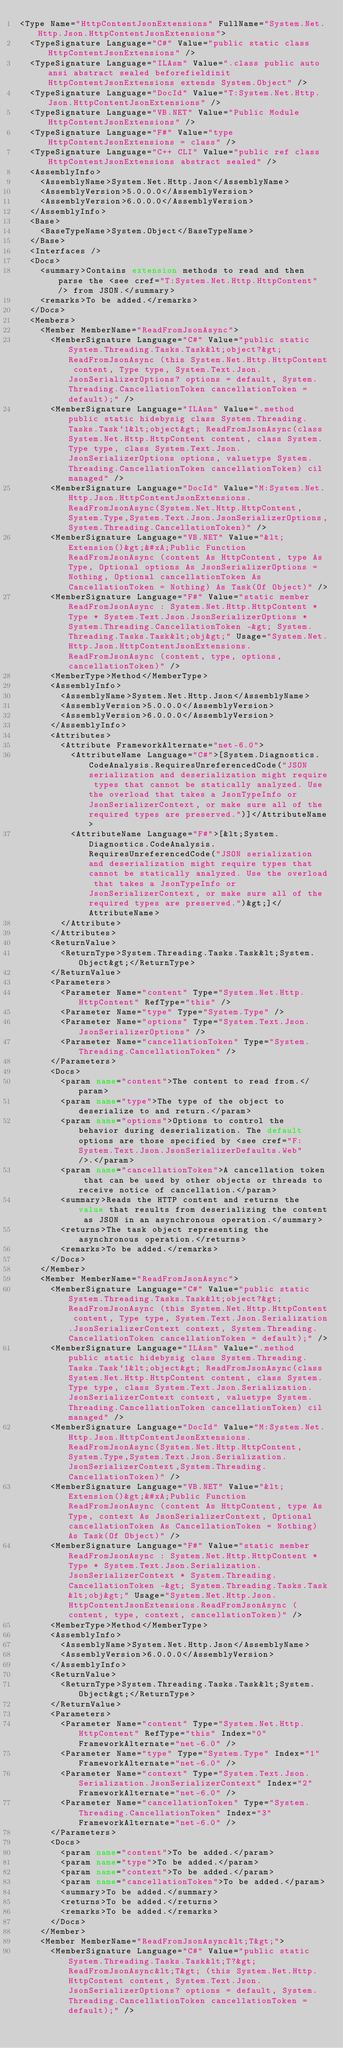Convert code to text. <code><loc_0><loc_0><loc_500><loc_500><_XML_><Type Name="HttpContentJsonExtensions" FullName="System.Net.Http.Json.HttpContentJsonExtensions">
  <TypeSignature Language="C#" Value="public static class HttpContentJsonExtensions" />
  <TypeSignature Language="ILAsm" Value=".class public auto ansi abstract sealed beforefieldinit HttpContentJsonExtensions extends System.Object" />
  <TypeSignature Language="DocId" Value="T:System.Net.Http.Json.HttpContentJsonExtensions" />
  <TypeSignature Language="VB.NET" Value="Public Module HttpContentJsonExtensions" />
  <TypeSignature Language="F#" Value="type HttpContentJsonExtensions = class" />
  <TypeSignature Language="C++ CLI" Value="public ref class HttpContentJsonExtensions abstract sealed" />
  <AssemblyInfo>
    <AssemblyName>System.Net.Http.Json</AssemblyName>
    <AssemblyVersion>5.0.0.0</AssemblyVersion>
    <AssemblyVersion>6.0.0.0</AssemblyVersion>
  </AssemblyInfo>
  <Base>
    <BaseTypeName>System.Object</BaseTypeName>
  </Base>
  <Interfaces />
  <Docs>
    <summary>Contains extension methods to read and then parse the <see cref="T:System.Net.Http.HttpContent" /> from JSON.</summary>
    <remarks>To be added.</remarks>
  </Docs>
  <Members>
    <Member MemberName="ReadFromJsonAsync">
      <MemberSignature Language="C#" Value="public static System.Threading.Tasks.Task&lt;object?&gt; ReadFromJsonAsync (this System.Net.Http.HttpContent content, Type type, System.Text.Json.JsonSerializerOptions? options = default, System.Threading.CancellationToken cancellationToken = default);" />
      <MemberSignature Language="ILAsm" Value=".method public static hidebysig class System.Threading.Tasks.Task`1&lt;object&gt; ReadFromJsonAsync(class System.Net.Http.HttpContent content, class System.Type type, class System.Text.Json.JsonSerializerOptions options, valuetype System.Threading.CancellationToken cancellationToken) cil managed" />
      <MemberSignature Language="DocId" Value="M:System.Net.Http.Json.HttpContentJsonExtensions.ReadFromJsonAsync(System.Net.Http.HttpContent,System.Type,System.Text.Json.JsonSerializerOptions,System.Threading.CancellationToken)" />
      <MemberSignature Language="VB.NET" Value="&lt;Extension()&gt;&#xA;Public Function ReadFromJsonAsync (content As HttpContent, type As Type, Optional options As JsonSerializerOptions = Nothing, Optional cancellationToken As CancellationToken = Nothing) As Task(Of Object)" />
      <MemberSignature Language="F#" Value="static member ReadFromJsonAsync : System.Net.Http.HttpContent * Type * System.Text.Json.JsonSerializerOptions * System.Threading.CancellationToken -&gt; System.Threading.Tasks.Task&lt;obj&gt;" Usage="System.Net.Http.Json.HttpContentJsonExtensions.ReadFromJsonAsync (content, type, options, cancellationToken)" />
      <MemberType>Method</MemberType>
      <AssemblyInfo>
        <AssemblyName>System.Net.Http.Json</AssemblyName>
        <AssemblyVersion>5.0.0.0</AssemblyVersion>
        <AssemblyVersion>6.0.0.0</AssemblyVersion>
      </AssemblyInfo>
      <Attributes>
        <Attribute FrameworkAlternate="net-6.0">
          <AttributeName Language="C#">[System.Diagnostics.CodeAnalysis.RequiresUnreferencedCode("JSON serialization and deserialization might require types that cannot be statically analyzed. Use the overload that takes a JsonTypeInfo or JsonSerializerContext, or make sure all of the required types are preserved.")]</AttributeName>
          <AttributeName Language="F#">[&lt;System.Diagnostics.CodeAnalysis.RequiresUnreferencedCode("JSON serialization and deserialization might require types that cannot be statically analyzed. Use the overload that takes a JsonTypeInfo or JsonSerializerContext, or make sure all of the required types are preserved.")&gt;]</AttributeName>
        </Attribute>
      </Attributes>
      <ReturnValue>
        <ReturnType>System.Threading.Tasks.Task&lt;System.Object&gt;</ReturnType>
      </ReturnValue>
      <Parameters>
        <Parameter Name="content" Type="System.Net.Http.HttpContent" RefType="this" />
        <Parameter Name="type" Type="System.Type" />
        <Parameter Name="options" Type="System.Text.Json.JsonSerializerOptions" />
        <Parameter Name="cancellationToken" Type="System.Threading.CancellationToken" />
      </Parameters>
      <Docs>
        <param name="content">The content to read from.</param>
        <param name="type">The type of the object to deserialize to and return.</param>
        <param name="options">Options to control the behavior during deserialization. The default options are those specified by <see cref="F:System.Text.Json.JsonSerializerDefaults.Web" />.</param>
        <param name="cancellationToken">A cancellation token that can be used by other objects or threads to receive notice of cancellation.</param>
        <summary>Reads the HTTP content and returns the value that results from deserializing the content as JSON in an asynchronous operation.</summary>
        <returns>The task object representing the asynchronous operation.</returns>
        <remarks>To be added.</remarks>
      </Docs>
    </Member>
    <Member MemberName="ReadFromJsonAsync">
      <MemberSignature Language="C#" Value="public static System.Threading.Tasks.Task&lt;object?&gt; ReadFromJsonAsync (this System.Net.Http.HttpContent content, Type type, System.Text.Json.Serialization.JsonSerializerContext context, System.Threading.CancellationToken cancellationToken = default);" />
      <MemberSignature Language="ILAsm" Value=".method public static hidebysig class System.Threading.Tasks.Task`1&lt;object&gt; ReadFromJsonAsync(class System.Net.Http.HttpContent content, class System.Type type, class System.Text.Json.Serialization.JsonSerializerContext context, valuetype System.Threading.CancellationToken cancellationToken) cil managed" />
      <MemberSignature Language="DocId" Value="M:System.Net.Http.Json.HttpContentJsonExtensions.ReadFromJsonAsync(System.Net.Http.HttpContent,System.Type,System.Text.Json.Serialization.JsonSerializerContext,System.Threading.CancellationToken)" />
      <MemberSignature Language="VB.NET" Value="&lt;Extension()&gt;&#xA;Public Function ReadFromJsonAsync (content As HttpContent, type As Type, context As JsonSerializerContext, Optional cancellationToken As CancellationToken = Nothing) As Task(Of Object)" />
      <MemberSignature Language="F#" Value="static member ReadFromJsonAsync : System.Net.Http.HttpContent * Type * System.Text.Json.Serialization.JsonSerializerContext * System.Threading.CancellationToken -&gt; System.Threading.Tasks.Task&lt;obj&gt;" Usage="System.Net.Http.Json.HttpContentJsonExtensions.ReadFromJsonAsync (content, type, context, cancellationToken)" />
      <MemberType>Method</MemberType>
      <AssemblyInfo>
        <AssemblyName>System.Net.Http.Json</AssemblyName>
        <AssemblyVersion>6.0.0.0</AssemblyVersion>
      </AssemblyInfo>
      <ReturnValue>
        <ReturnType>System.Threading.Tasks.Task&lt;System.Object&gt;</ReturnType>
      </ReturnValue>
      <Parameters>
        <Parameter Name="content" Type="System.Net.Http.HttpContent" RefType="this" Index="0" FrameworkAlternate="net-6.0" />
        <Parameter Name="type" Type="System.Type" Index="1" FrameworkAlternate="net-6.0" />
        <Parameter Name="context" Type="System.Text.Json.Serialization.JsonSerializerContext" Index="2" FrameworkAlternate="net-6.0" />
        <Parameter Name="cancellationToken" Type="System.Threading.CancellationToken" Index="3" FrameworkAlternate="net-6.0" />
      </Parameters>
      <Docs>
        <param name="content">To be added.</param>
        <param name="type">To be added.</param>
        <param name="context">To be added.</param>
        <param name="cancellationToken">To be added.</param>
        <summary>To be added.</summary>
        <returns>To be added.</returns>
        <remarks>To be added.</remarks>
      </Docs>
    </Member>
    <Member MemberName="ReadFromJsonAsync&lt;T&gt;">
      <MemberSignature Language="C#" Value="public static System.Threading.Tasks.Task&lt;T?&gt; ReadFromJsonAsync&lt;T&gt; (this System.Net.Http.HttpContent content, System.Text.Json.JsonSerializerOptions? options = default, System.Threading.CancellationToken cancellationToken = default);" /></code> 